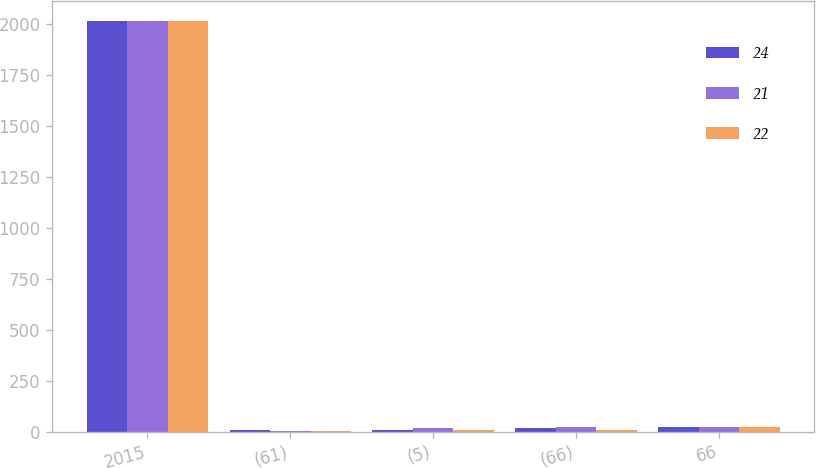Convert chart. <chart><loc_0><loc_0><loc_500><loc_500><stacked_bar_chart><ecel><fcel>2015<fcel>(61)<fcel>(5)<fcel>(66)<fcel>66<nl><fcel>24<fcel>2015<fcel>6<fcel>10<fcel>16<fcel>24<nl><fcel>21<fcel>2014<fcel>5<fcel>17<fcel>22<fcel>22<nl><fcel>22<fcel>2014<fcel>1<fcel>9<fcel>8<fcel>21<nl></chart> 